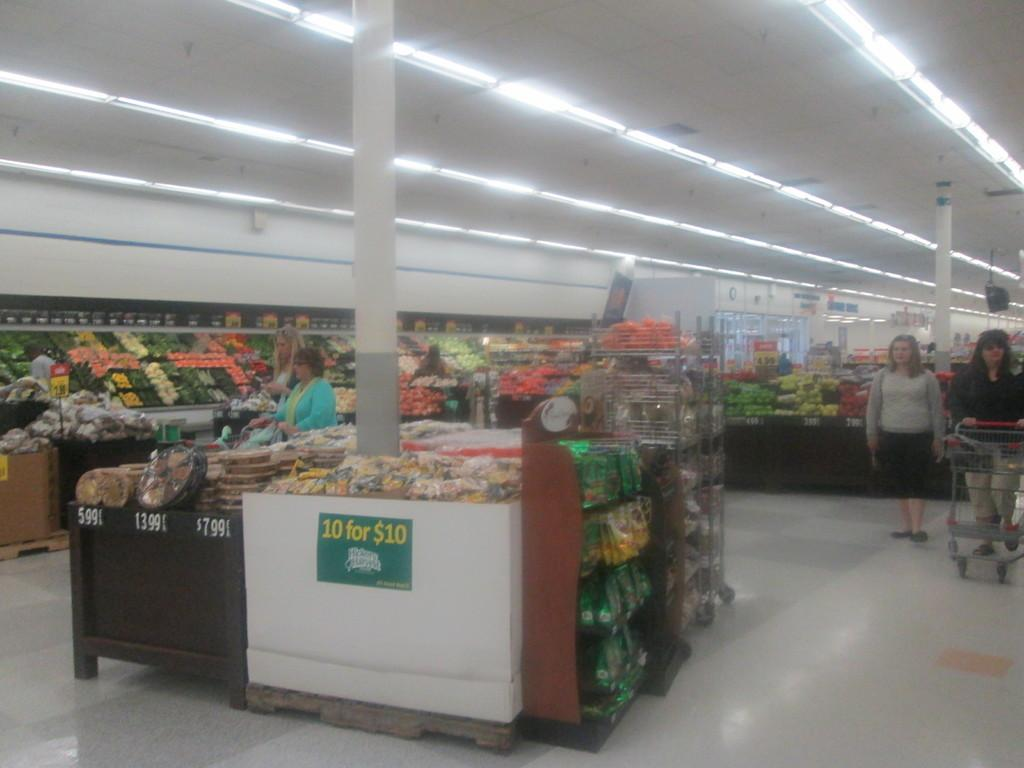What type of location is depicted in the image? The image depicts the interior of a supermarket. What can be found in a supermarket? Food items are visible in the image. What might someone use to carry their groceries in a supermarket? There is a person holding a shopping trolley in the image. What helps to illuminate the supermarket in the image? Lights are visible at the top of the image. Can you see any rabbits or robins in the image? No, there are no rabbits or robins present in the image. What type of crack is visible on the floor in the image? There is no crack visible on the floor in the image. 